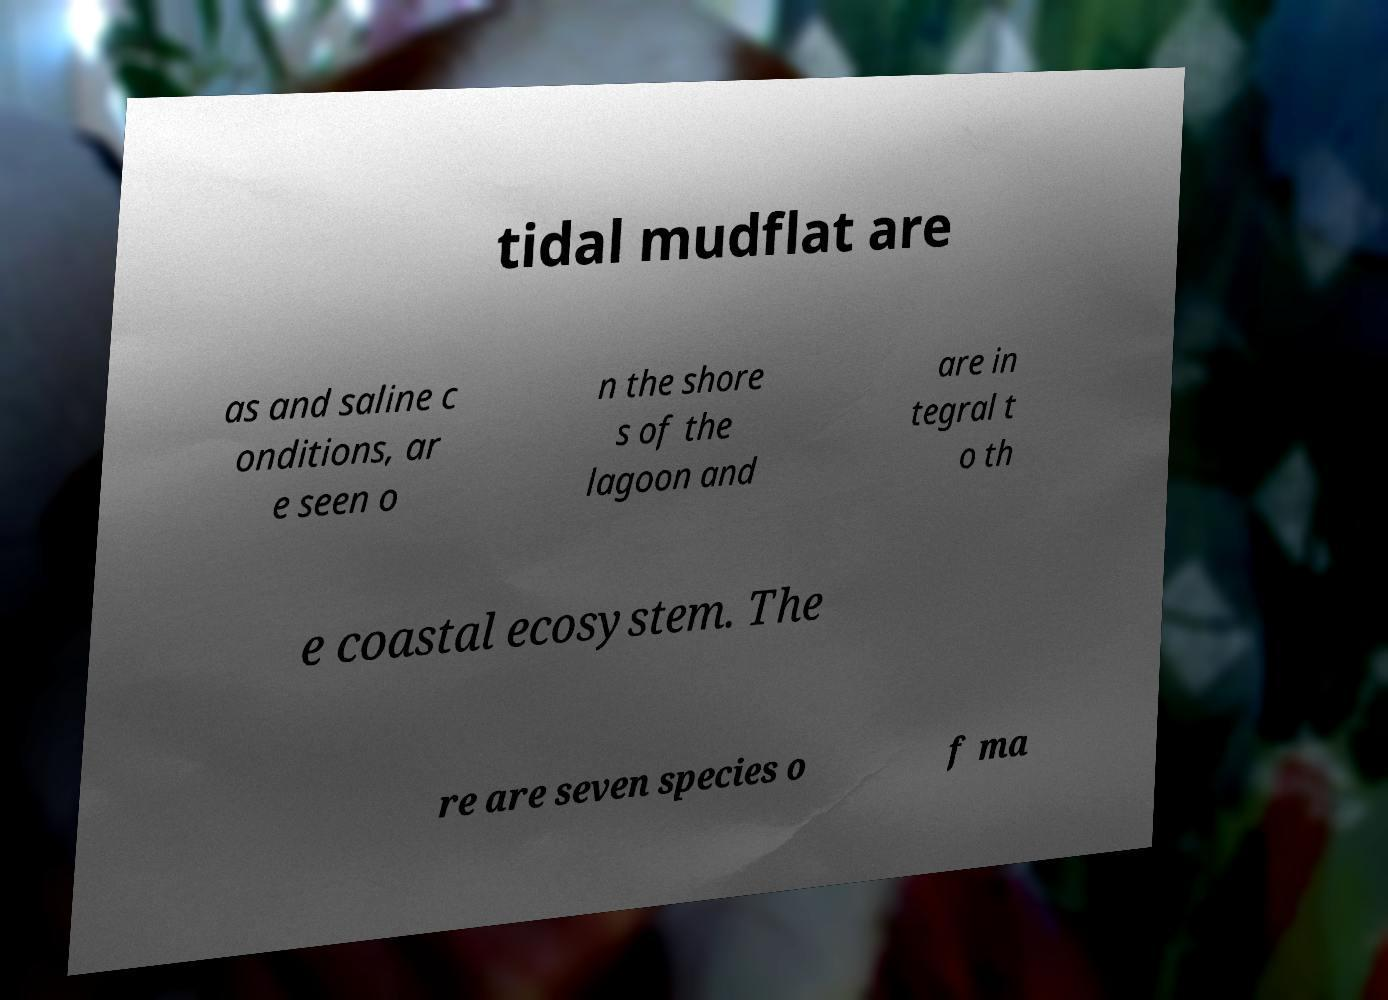Could you extract and type out the text from this image? tidal mudflat are as and saline c onditions, ar e seen o n the shore s of the lagoon and are in tegral t o th e coastal ecosystem. The re are seven species o f ma 